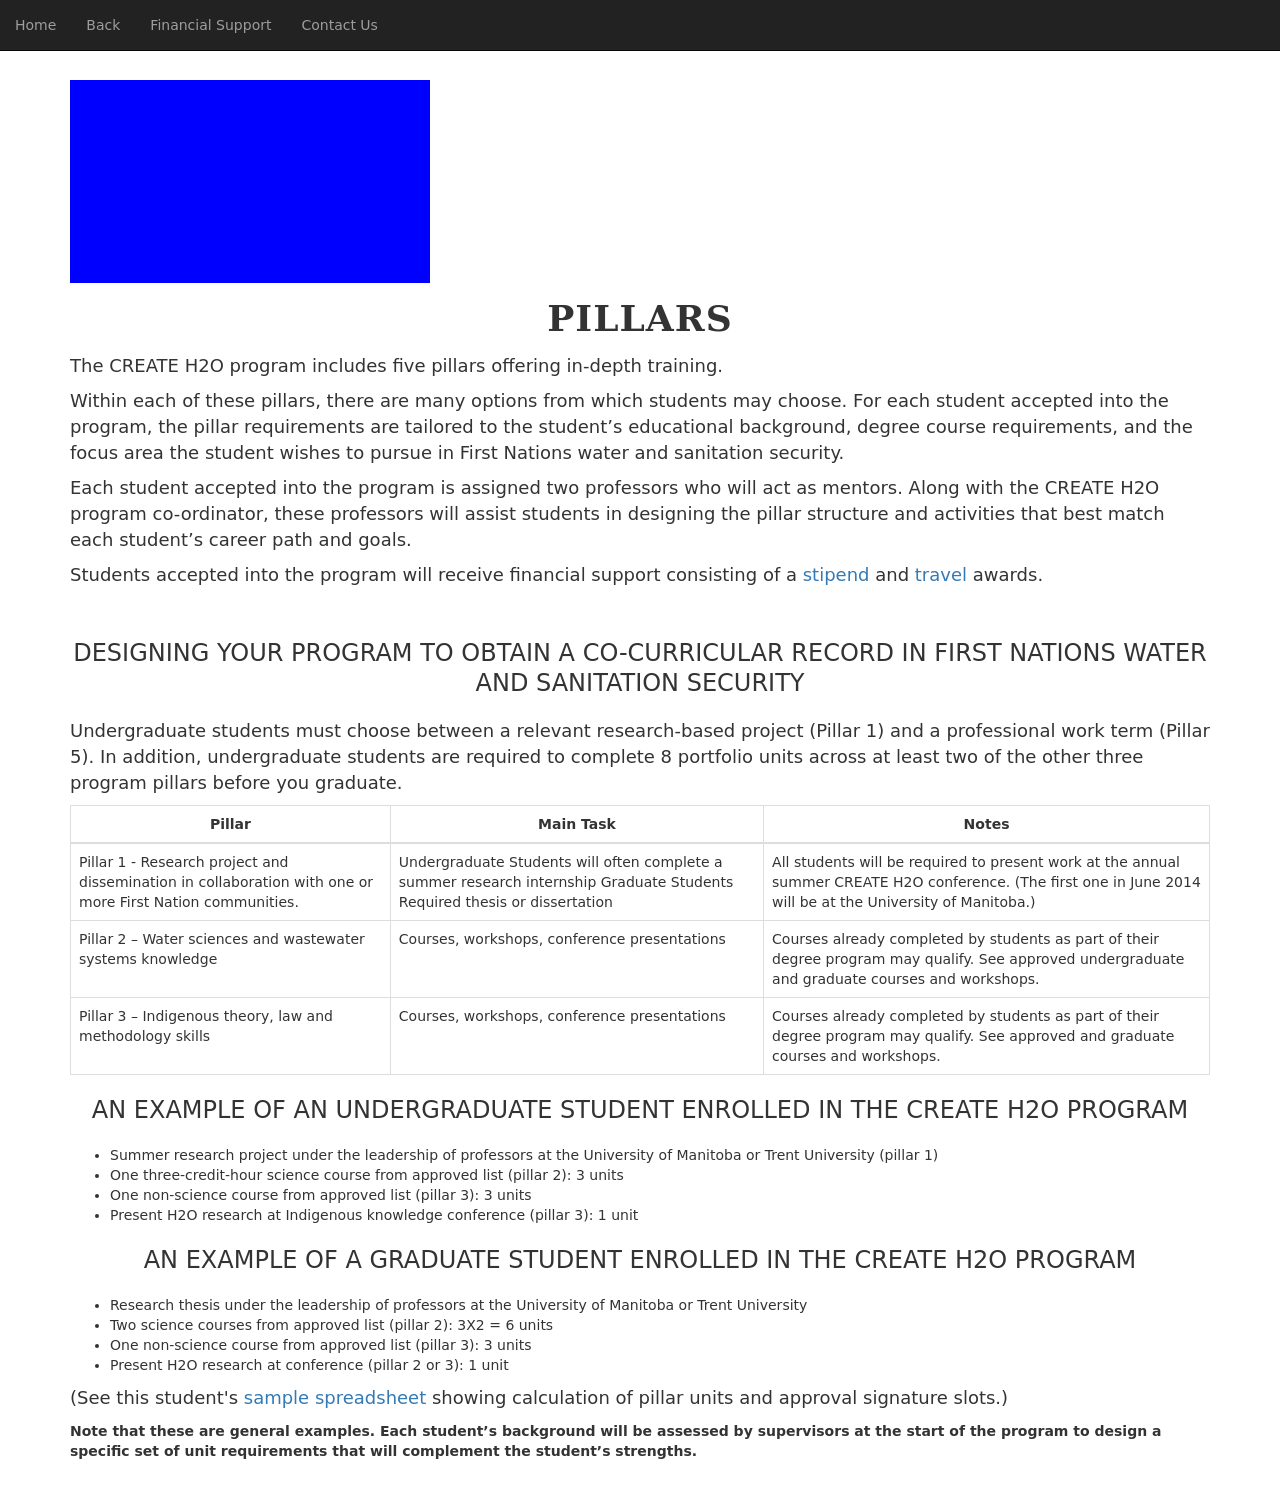What inspired the design elements and layout you see on this educational website? The website layout and design elements appear to be tailored to provide a clear and structured educational platform. The use of a consistent and straightforward layout with sections clearly differentiated by headings ensures that information is easily accessible. The minimalistic color scheme likely aims to reduce distractions, while the emphasis on text and information blocks highlights the educational purpose of the website. 
Can you explain how the pillared approach shown benefits the students programmatically? The pillared approach organizes the educational content into distinct but interconnected areas, allowing students to receive a holistic yet focused training experience. Each pillar represents a core area of knowledge or skill that is crucial for the field of First Nations water and sanitation security. This structure helps ensure comprehensive coverage of all necessary topics and provides flexibility for students to engage with material that directly complements their personal educational and career goals. 